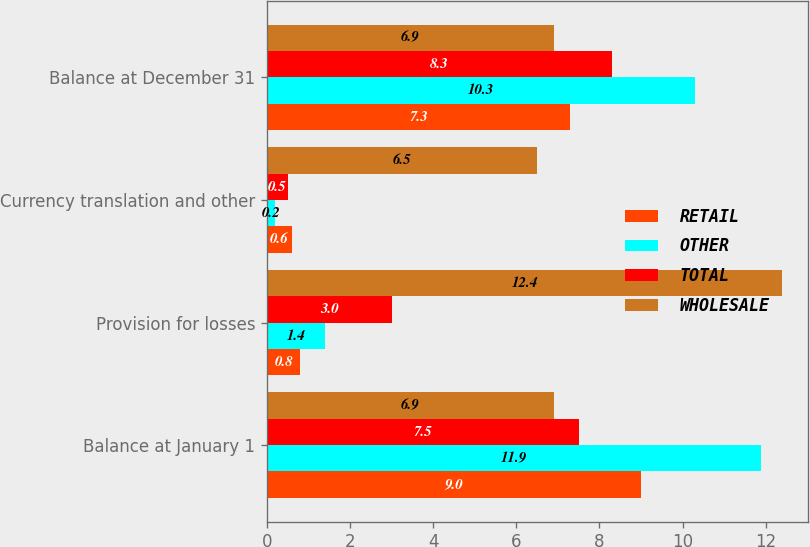Convert chart to OTSL. <chart><loc_0><loc_0><loc_500><loc_500><stacked_bar_chart><ecel><fcel>Balance at January 1<fcel>Provision for losses<fcel>Currency translation and other<fcel>Balance at December 31<nl><fcel>RETAIL<fcel>9<fcel>0.8<fcel>0.6<fcel>7.3<nl><fcel>OTHER<fcel>11.9<fcel>1.4<fcel>0.2<fcel>10.3<nl><fcel>TOTAL<fcel>7.5<fcel>3<fcel>0.5<fcel>8.3<nl><fcel>WHOLESALE<fcel>6.9<fcel>12.4<fcel>6.5<fcel>6.9<nl></chart> 